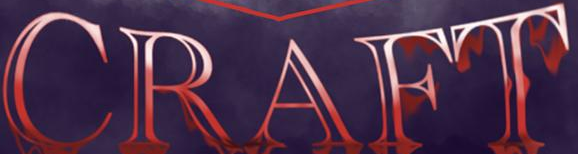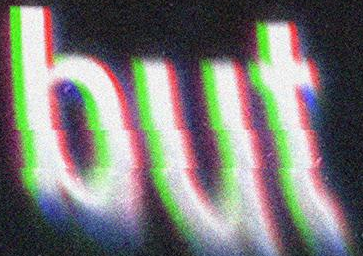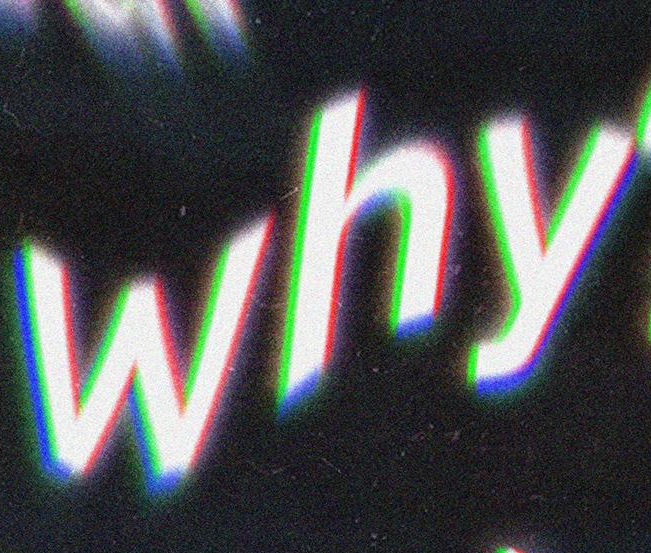What text is displayed in these images sequentially, separated by a semicolon? CRAFT; but; why 